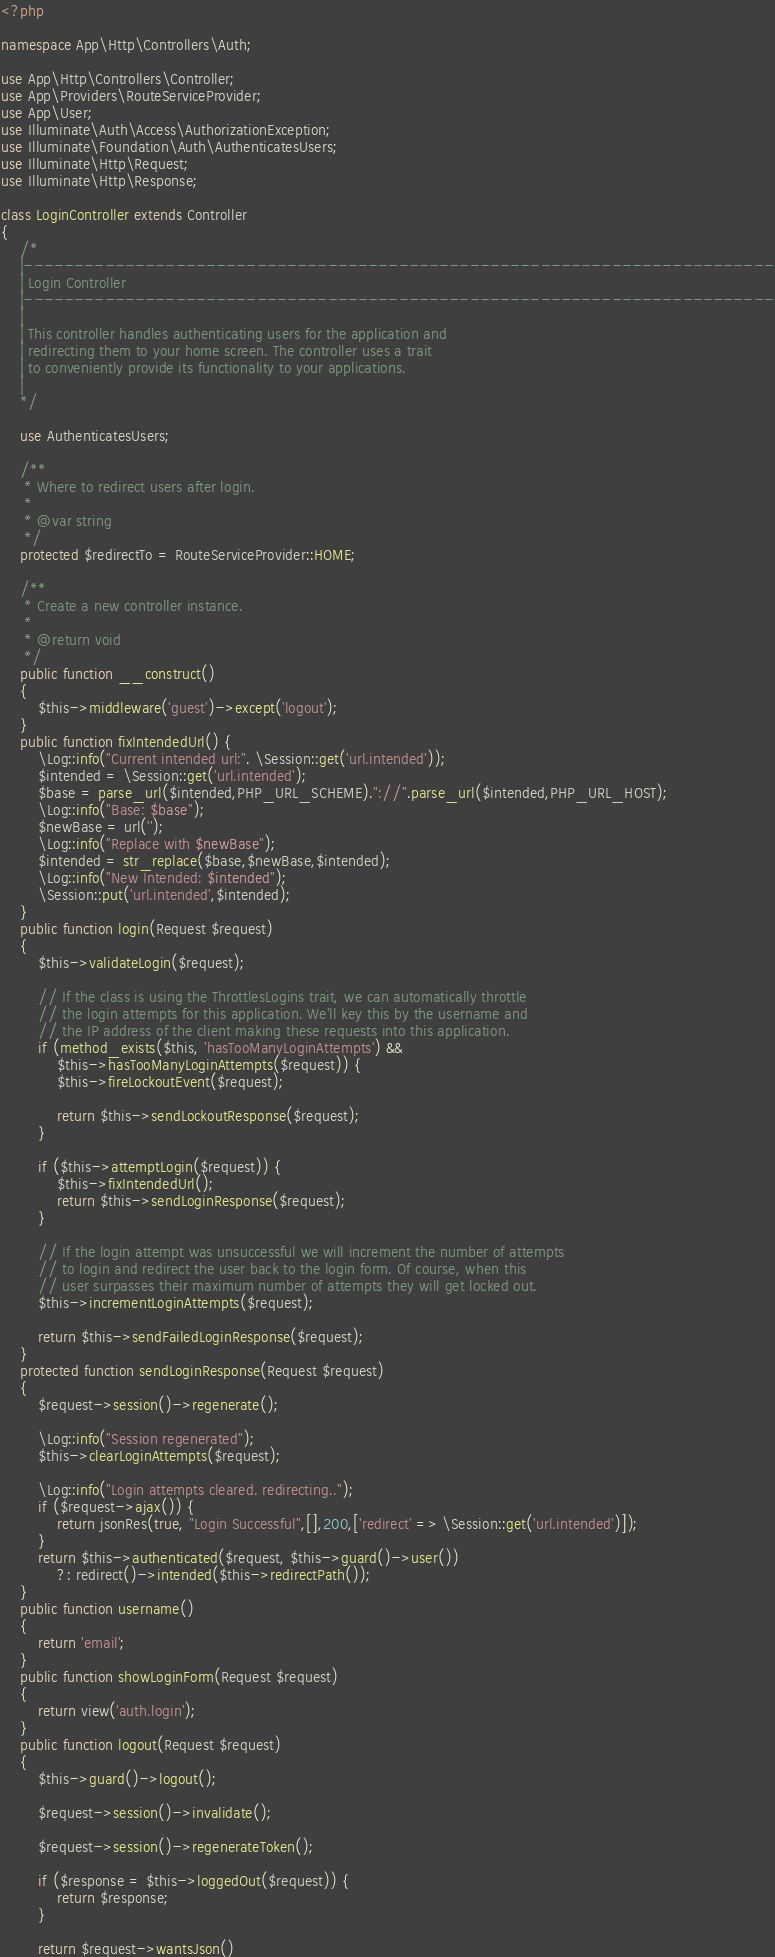<code> <loc_0><loc_0><loc_500><loc_500><_PHP_><?php

namespace App\Http\Controllers\Auth;

use App\Http\Controllers\Controller;
use App\Providers\RouteServiceProvider;
use App\User;
use Illuminate\Auth\Access\AuthorizationException;
use Illuminate\Foundation\Auth\AuthenticatesUsers;
use Illuminate\Http\Request;
use Illuminate\Http\Response;

class LoginController extends Controller
{
    /*
    |--------------------------------------------------------------------------
    | Login Controller
    |--------------------------------------------------------------------------
    |
    | This controller handles authenticating users for the application and
    | redirecting them to your home screen. The controller uses a trait
    | to conveniently provide its functionality to your applications.
    |
    */

    use AuthenticatesUsers;

    /**
     * Where to redirect users after login.
     *
     * @var string
     */
    protected $redirectTo = RouteServiceProvider::HOME;

    /**
     * Create a new controller instance.
     *
     * @return void
     */
    public function __construct()
    {
        $this->middleware('guest')->except('logout');
    }
    public function fixIntendedUrl() {
        \Log::info("Current intended url:". \Session::get('url.intended'));
        $intended = \Session::get('url.intended');
        $base = parse_url($intended,PHP_URL_SCHEME)."://".parse_url($intended,PHP_URL_HOST);
        \Log::info("Base: $base");
        $newBase = url('');
        \Log::info("Replace with $newBase");
        $intended = str_replace($base,$newBase,$intended);
        \Log::info("New Intended: $intended");
        \Session::put('url.intended',$intended);
    }
    public function login(Request $request)
    {
        $this->validateLogin($request);

        // If the class is using the ThrottlesLogins trait, we can automatically throttle
        // the login attempts for this application. We'll key this by the username and
        // the IP address of the client making these requests into this application.
        if (method_exists($this, 'hasTooManyLoginAttempts') &&
            $this->hasTooManyLoginAttempts($request)) {
            $this->fireLockoutEvent($request);

            return $this->sendLockoutResponse($request);
        }

        if ($this->attemptLogin($request)) {
            $this->fixIntendedUrl();
            return $this->sendLoginResponse($request);
        }

        // If the login attempt was unsuccessful we will increment the number of attempts
        // to login and redirect the user back to the login form. Of course, when this
        // user surpasses their maximum number of attempts they will get locked out.
        $this->incrementLoginAttempts($request);

        return $this->sendFailedLoginResponse($request);
    }
    protected function sendLoginResponse(Request $request)
    {
        $request->session()->regenerate();

        \Log::info("Session regenerated");
        $this->clearLoginAttempts($request);

        \Log::info("Login attempts cleared. redirecting..");
        if ($request->ajax()) {
            return jsonRes(true, "Login Successful",[],200,['redirect' => \Session::get('url.intended')]);
        }
        return $this->authenticated($request, $this->guard()->user())
            ?: redirect()->intended($this->redirectPath());
    }
    public function username()
    {
        return 'email';
    }
    public function showLoginForm(Request $request)
    {
        return view('auth.login');
    }
    public function logout(Request $request)
    {
        $this->guard()->logout();

        $request->session()->invalidate();

        $request->session()->regenerateToken();

        if ($response = $this->loggedOut($request)) {
            return $response;
        }

        return $request->wantsJson()</code> 